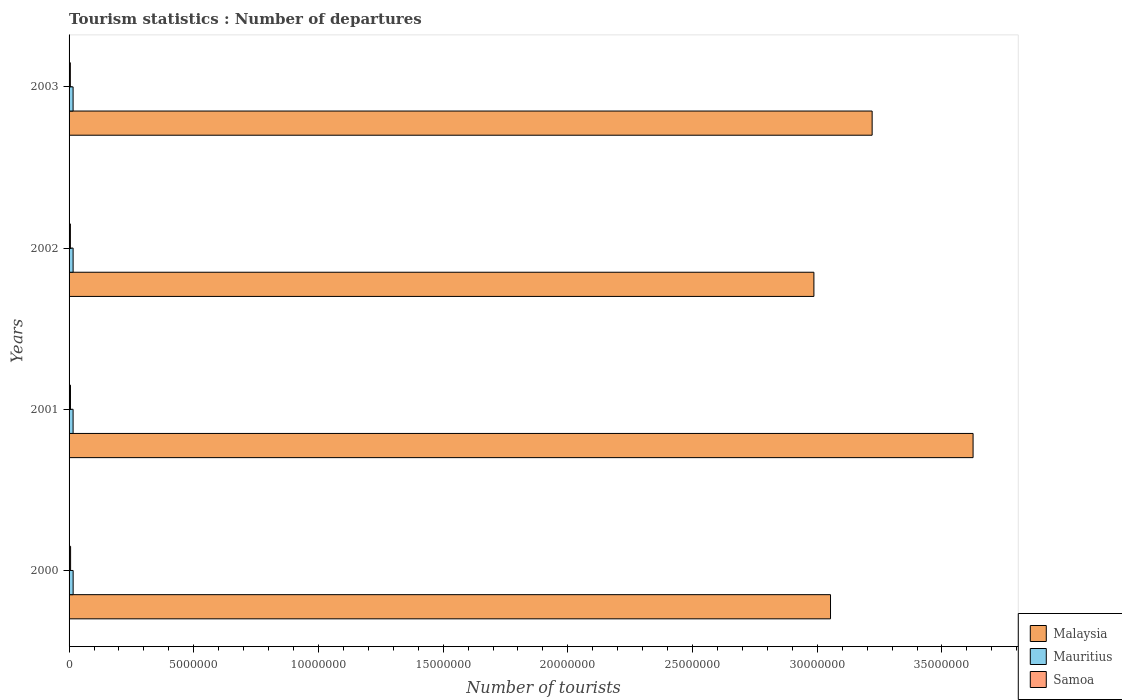How many different coloured bars are there?
Keep it short and to the point. 3. How many groups of bars are there?
Offer a terse response. 4. Are the number of bars per tick equal to the number of legend labels?
Your response must be concise. Yes. How many bars are there on the 2nd tick from the top?
Ensure brevity in your answer.  3. How many bars are there on the 4th tick from the bottom?
Give a very brief answer. 3. In how many cases, is the number of bars for a given year not equal to the number of legend labels?
Make the answer very short. 0. What is the number of tourist departures in Malaysia in 2000?
Your answer should be compact. 3.05e+07. Across all years, what is the maximum number of tourist departures in Mauritius?
Provide a succinct answer. 1.63e+05. Across all years, what is the minimum number of tourist departures in Samoa?
Ensure brevity in your answer.  5.10e+04. In which year was the number of tourist departures in Samoa minimum?
Provide a succinct answer. 2003. What is the total number of tourist departures in Malaysia in the graph?
Your answer should be very brief. 1.29e+08. What is the difference between the number of tourist departures in Malaysia in 2000 and that in 2001?
Offer a terse response. -5.72e+06. What is the difference between the number of tourist departures in Mauritius in 2001 and the number of tourist departures in Samoa in 2003?
Offer a very short reply. 1.10e+05. What is the average number of tourist departures in Mauritius per year?
Keep it short and to the point. 1.62e+05. In the year 2001, what is the difference between the number of tourist departures in Samoa and number of tourist departures in Mauritius?
Offer a terse response. -1.05e+05. In how many years, is the number of tourist departures in Samoa greater than 21000000 ?
Your response must be concise. 0. What is the ratio of the number of tourist departures in Samoa in 2001 to that in 2002?
Offer a very short reply. 1.06. Is the number of tourist departures in Malaysia in 2000 less than that in 2003?
Your answer should be very brief. Yes. What is the difference between the highest and the second highest number of tourist departures in Malaysia?
Offer a terse response. 4.05e+06. What is the difference between the highest and the lowest number of tourist departures in Malaysia?
Provide a short and direct response. 6.38e+06. In how many years, is the number of tourist departures in Malaysia greater than the average number of tourist departures in Malaysia taken over all years?
Ensure brevity in your answer.  1. Is the sum of the number of tourist departures in Samoa in 2002 and 2003 greater than the maximum number of tourist departures in Mauritius across all years?
Offer a terse response. No. What does the 1st bar from the top in 2002 represents?
Your answer should be compact. Samoa. What does the 1st bar from the bottom in 2003 represents?
Make the answer very short. Malaysia. How many bars are there?
Offer a very short reply. 12. Are all the bars in the graph horizontal?
Offer a very short reply. Yes. How many years are there in the graph?
Ensure brevity in your answer.  4. What is the title of the graph?
Your answer should be compact. Tourism statistics : Number of departures. What is the label or title of the X-axis?
Offer a terse response. Number of tourists. What is the Number of tourists of Malaysia in 2000?
Your response must be concise. 3.05e+07. What is the Number of tourists in Mauritius in 2000?
Your response must be concise. 1.63e+05. What is the Number of tourists of Samoa in 2000?
Make the answer very short. 6.10e+04. What is the Number of tourists in Malaysia in 2001?
Your answer should be very brief. 3.62e+07. What is the Number of tourists of Mauritius in 2001?
Provide a short and direct response. 1.61e+05. What is the Number of tourists in Samoa in 2001?
Keep it short and to the point. 5.60e+04. What is the Number of tourists in Malaysia in 2002?
Provide a short and direct response. 2.99e+07. What is the Number of tourists in Mauritius in 2002?
Offer a terse response. 1.62e+05. What is the Number of tourists in Samoa in 2002?
Offer a terse response. 5.30e+04. What is the Number of tourists in Malaysia in 2003?
Your response must be concise. 3.22e+07. What is the Number of tourists in Mauritius in 2003?
Provide a succinct answer. 1.61e+05. What is the Number of tourists in Samoa in 2003?
Offer a very short reply. 5.10e+04. Across all years, what is the maximum Number of tourists in Malaysia?
Offer a very short reply. 3.62e+07. Across all years, what is the maximum Number of tourists of Mauritius?
Keep it short and to the point. 1.63e+05. Across all years, what is the maximum Number of tourists in Samoa?
Keep it short and to the point. 6.10e+04. Across all years, what is the minimum Number of tourists of Malaysia?
Make the answer very short. 2.99e+07. Across all years, what is the minimum Number of tourists in Mauritius?
Offer a terse response. 1.61e+05. Across all years, what is the minimum Number of tourists of Samoa?
Offer a very short reply. 5.10e+04. What is the total Number of tourists of Malaysia in the graph?
Offer a terse response. 1.29e+08. What is the total Number of tourists in Mauritius in the graph?
Keep it short and to the point. 6.47e+05. What is the total Number of tourists in Samoa in the graph?
Offer a very short reply. 2.21e+05. What is the difference between the Number of tourists in Malaysia in 2000 and that in 2001?
Keep it short and to the point. -5.72e+06. What is the difference between the Number of tourists of Mauritius in 2000 and that in 2001?
Provide a succinct answer. 2000. What is the difference between the Number of tourists of Samoa in 2000 and that in 2001?
Keep it short and to the point. 5000. What is the difference between the Number of tourists of Malaysia in 2000 and that in 2002?
Offer a terse response. 6.66e+05. What is the difference between the Number of tourists in Mauritius in 2000 and that in 2002?
Your answer should be very brief. 1000. What is the difference between the Number of tourists in Samoa in 2000 and that in 2002?
Provide a short and direct response. 8000. What is the difference between the Number of tourists in Malaysia in 2000 and that in 2003?
Offer a very short reply. -1.67e+06. What is the difference between the Number of tourists in Mauritius in 2000 and that in 2003?
Ensure brevity in your answer.  2000. What is the difference between the Number of tourists in Malaysia in 2001 and that in 2002?
Offer a very short reply. 6.38e+06. What is the difference between the Number of tourists in Mauritius in 2001 and that in 2002?
Offer a terse response. -1000. What is the difference between the Number of tourists in Samoa in 2001 and that in 2002?
Ensure brevity in your answer.  3000. What is the difference between the Number of tourists of Malaysia in 2001 and that in 2003?
Provide a succinct answer. 4.05e+06. What is the difference between the Number of tourists in Malaysia in 2002 and that in 2003?
Offer a terse response. -2.34e+06. What is the difference between the Number of tourists of Malaysia in 2000 and the Number of tourists of Mauritius in 2001?
Give a very brief answer. 3.04e+07. What is the difference between the Number of tourists in Malaysia in 2000 and the Number of tourists in Samoa in 2001?
Offer a terse response. 3.05e+07. What is the difference between the Number of tourists in Mauritius in 2000 and the Number of tourists in Samoa in 2001?
Offer a terse response. 1.07e+05. What is the difference between the Number of tourists in Malaysia in 2000 and the Number of tourists in Mauritius in 2002?
Provide a succinct answer. 3.04e+07. What is the difference between the Number of tourists in Malaysia in 2000 and the Number of tourists in Samoa in 2002?
Provide a succinct answer. 3.05e+07. What is the difference between the Number of tourists of Mauritius in 2000 and the Number of tourists of Samoa in 2002?
Make the answer very short. 1.10e+05. What is the difference between the Number of tourists of Malaysia in 2000 and the Number of tourists of Mauritius in 2003?
Keep it short and to the point. 3.04e+07. What is the difference between the Number of tourists of Malaysia in 2000 and the Number of tourists of Samoa in 2003?
Offer a terse response. 3.05e+07. What is the difference between the Number of tourists in Mauritius in 2000 and the Number of tourists in Samoa in 2003?
Offer a very short reply. 1.12e+05. What is the difference between the Number of tourists in Malaysia in 2001 and the Number of tourists in Mauritius in 2002?
Provide a short and direct response. 3.61e+07. What is the difference between the Number of tourists of Malaysia in 2001 and the Number of tourists of Samoa in 2002?
Your answer should be very brief. 3.62e+07. What is the difference between the Number of tourists of Mauritius in 2001 and the Number of tourists of Samoa in 2002?
Ensure brevity in your answer.  1.08e+05. What is the difference between the Number of tourists of Malaysia in 2001 and the Number of tourists of Mauritius in 2003?
Make the answer very short. 3.61e+07. What is the difference between the Number of tourists in Malaysia in 2001 and the Number of tourists in Samoa in 2003?
Give a very brief answer. 3.62e+07. What is the difference between the Number of tourists in Malaysia in 2002 and the Number of tourists in Mauritius in 2003?
Your answer should be compact. 2.97e+07. What is the difference between the Number of tourists of Malaysia in 2002 and the Number of tourists of Samoa in 2003?
Give a very brief answer. 2.98e+07. What is the difference between the Number of tourists in Mauritius in 2002 and the Number of tourists in Samoa in 2003?
Make the answer very short. 1.11e+05. What is the average Number of tourists in Malaysia per year?
Offer a very short reply. 3.22e+07. What is the average Number of tourists of Mauritius per year?
Offer a very short reply. 1.62e+05. What is the average Number of tourists in Samoa per year?
Ensure brevity in your answer.  5.52e+04. In the year 2000, what is the difference between the Number of tourists in Malaysia and Number of tourists in Mauritius?
Your response must be concise. 3.04e+07. In the year 2000, what is the difference between the Number of tourists of Malaysia and Number of tourists of Samoa?
Offer a terse response. 3.05e+07. In the year 2000, what is the difference between the Number of tourists in Mauritius and Number of tourists in Samoa?
Make the answer very short. 1.02e+05. In the year 2001, what is the difference between the Number of tourists in Malaysia and Number of tourists in Mauritius?
Give a very brief answer. 3.61e+07. In the year 2001, what is the difference between the Number of tourists in Malaysia and Number of tourists in Samoa?
Give a very brief answer. 3.62e+07. In the year 2001, what is the difference between the Number of tourists of Mauritius and Number of tourists of Samoa?
Provide a succinct answer. 1.05e+05. In the year 2002, what is the difference between the Number of tourists of Malaysia and Number of tourists of Mauritius?
Offer a very short reply. 2.97e+07. In the year 2002, what is the difference between the Number of tourists in Malaysia and Number of tourists in Samoa?
Your answer should be compact. 2.98e+07. In the year 2002, what is the difference between the Number of tourists in Mauritius and Number of tourists in Samoa?
Offer a very short reply. 1.09e+05. In the year 2003, what is the difference between the Number of tourists in Malaysia and Number of tourists in Mauritius?
Keep it short and to the point. 3.20e+07. In the year 2003, what is the difference between the Number of tourists in Malaysia and Number of tourists in Samoa?
Provide a succinct answer. 3.22e+07. In the year 2003, what is the difference between the Number of tourists in Mauritius and Number of tourists in Samoa?
Give a very brief answer. 1.10e+05. What is the ratio of the Number of tourists of Malaysia in 2000 to that in 2001?
Provide a short and direct response. 0.84. What is the ratio of the Number of tourists of Mauritius in 2000 to that in 2001?
Provide a short and direct response. 1.01. What is the ratio of the Number of tourists in Samoa in 2000 to that in 2001?
Offer a terse response. 1.09. What is the ratio of the Number of tourists in Malaysia in 2000 to that in 2002?
Your answer should be very brief. 1.02. What is the ratio of the Number of tourists of Samoa in 2000 to that in 2002?
Keep it short and to the point. 1.15. What is the ratio of the Number of tourists of Malaysia in 2000 to that in 2003?
Offer a very short reply. 0.95. What is the ratio of the Number of tourists in Mauritius in 2000 to that in 2003?
Provide a short and direct response. 1.01. What is the ratio of the Number of tourists of Samoa in 2000 to that in 2003?
Offer a very short reply. 1.2. What is the ratio of the Number of tourists of Malaysia in 2001 to that in 2002?
Make the answer very short. 1.21. What is the ratio of the Number of tourists in Samoa in 2001 to that in 2002?
Provide a short and direct response. 1.06. What is the ratio of the Number of tourists in Malaysia in 2001 to that in 2003?
Your response must be concise. 1.13. What is the ratio of the Number of tourists in Samoa in 2001 to that in 2003?
Your answer should be compact. 1.1. What is the ratio of the Number of tourists in Malaysia in 2002 to that in 2003?
Offer a terse response. 0.93. What is the ratio of the Number of tourists in Samoa in 2002 to that in 2003?
Provide a succinct answer. 1.04. What is the difference between the highest and the second highest Number of tourists of Malaysia?
Offer a very short reply. 4.05e+06. What is the difference between the highest and the lowest Number of tourists of Malaysia?
Give a very brief answer. 6.38e+06. What is the difference between the highest and the lowest Number of tourists in Mauritius?
Provide a short and direct response. 2000. What is the difference between the highest and the lowest Number of tourists in Samoa?
Your answer should be very brief. 10000. 